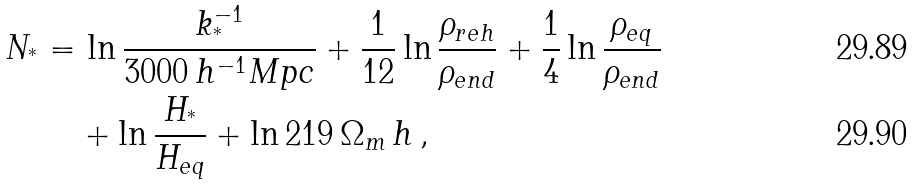Convert formula to latex. <formula><loc_0><loc_0><loc_500><loc_500>N _ { ^ { * } } = & \, \ln \frac { k _ { ^ { * } } ^ { - 1 } } { 3 0 0 0 \, h ^ { - 1 } M p c } + \frac { 1 } { 1 2 } \ln \frac { \rho _ { r e h } } { \rho _ { e n d } } + \frac { 1 } { 4 } \ln \frac { \rho _ { e q } } { \rho _ { e n d } } \\ & + \ln \frac { H _ { ^ { * } } } { H _ { e q } } + \ln 2 1 9 \, \Omega _ { m } \, h \, ,</formula> 